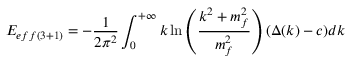Convert formula to latex. <formula><loc_0><loc_0><loc_500><loc_500>E _ { e f f ( 3 + 1 ) } = - \frac { 1 } { 2 \pi ^ { 2 } } \int _ { 0 } ^ { + \infty } k \ln \left ( \frac { k ^ { 2 } + m _ { f } ^ { 2 } } { m _ { f } ^ { 2 } } \right ) ( \Delta ( k ) - c ) d k</formula> 